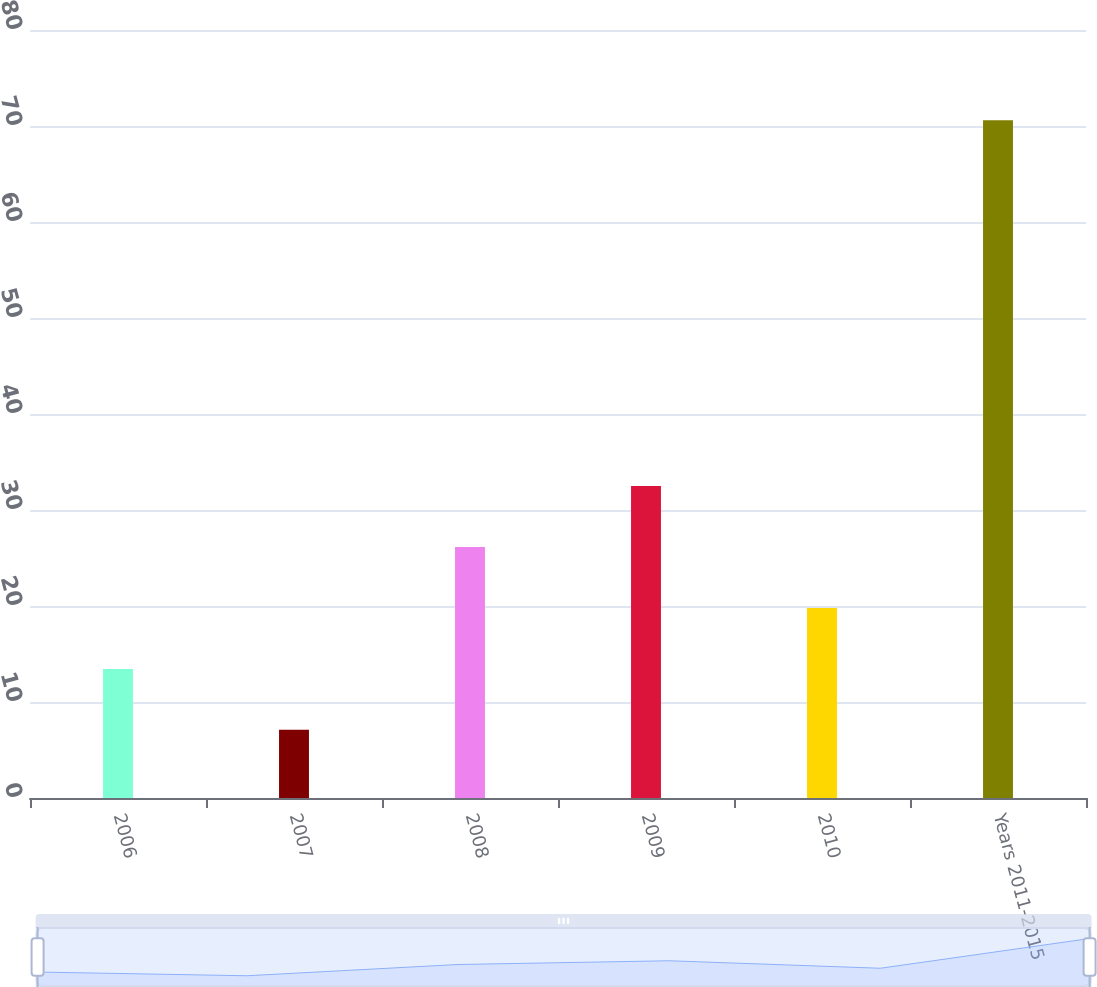Convert chart. <chart><loc_0><loc_0><loc_500><loc_500><bar_chart><fcel>2006<fcel>2007<fcel>2008<fcel>2009<fcel>2010<fcel>Years 2011-2015<nl><fcel>13.45<fcel>7.1<fcel>26.15<fcel>32.5<fcel>19.8<fcel>70.6<nl></chart> 